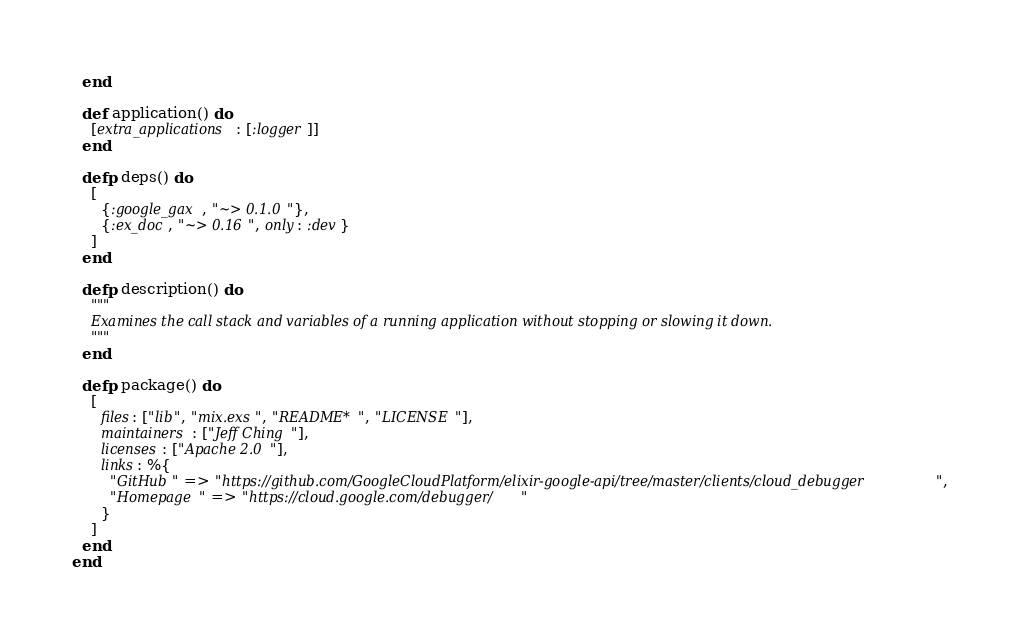<code> <loc_0><loc_0><loc_500><loc_500><_Elixir_>  end

  def application() do
    [extra_applications: [:logger]]
  end

  defp deps() do
    [
      {:google_gax, "~> 0.1.0"},
      {:ex_doc, "~> 0.16", only: :dev}
    ]
  end

  defp description() do
    """
    Examines the call stack and variables of a running application without stopping or slowing it down.
    """
  end

  defp package() do
    [
      files: ["lib", "mix.exs", "README*", "LICENSE"],
      maintainers: ["Jeff Ching"],
      licenses: ["Apache 2.0"],
      links: %{
        "GitHub" => "https://github.com/GoogleCloudPlatform/elixir-google-api/tree/master/clients/cloud_debugger",
        "Homepage" => "https://cloud.google.com/debugger/"
      }
    ]
  end
end
</code> 